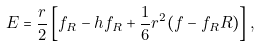Convert formula to latex. <formula><loc_0><loc_0><loc_500><loc_500>E = \frac { r } { 2 } \left [ f _ { R } - h f _ { R } + \frac { 1 } { 6 } r ^ { 2 } ( f - f _ { R } R ) \right ] ,</formula> 